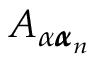Convert formula to latex. <formula><loc_0><loc_0><loc_500><loc_500>A _ { \alpha { \pm b \alpha } _ { n } }</formula> 